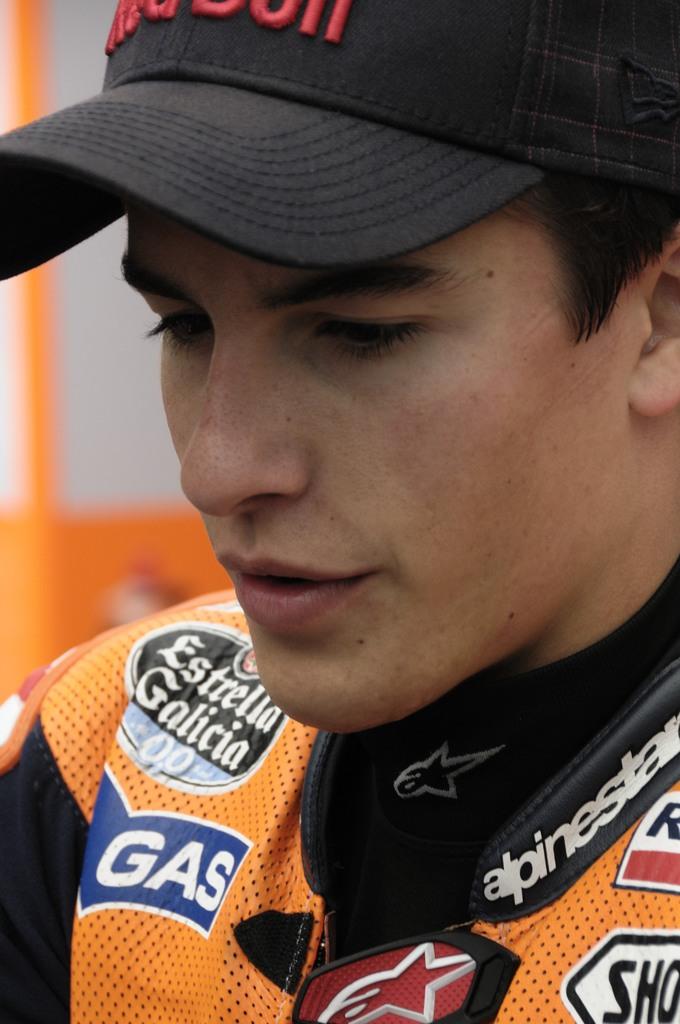What sponsor is on the jacket?
Ensure brevity in your answer.  Estrella galicia. What type of fuel is noted on the blue banner on his jersey?
Make the answer very short. Gas. 